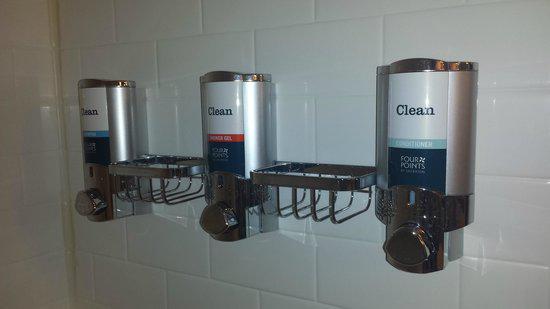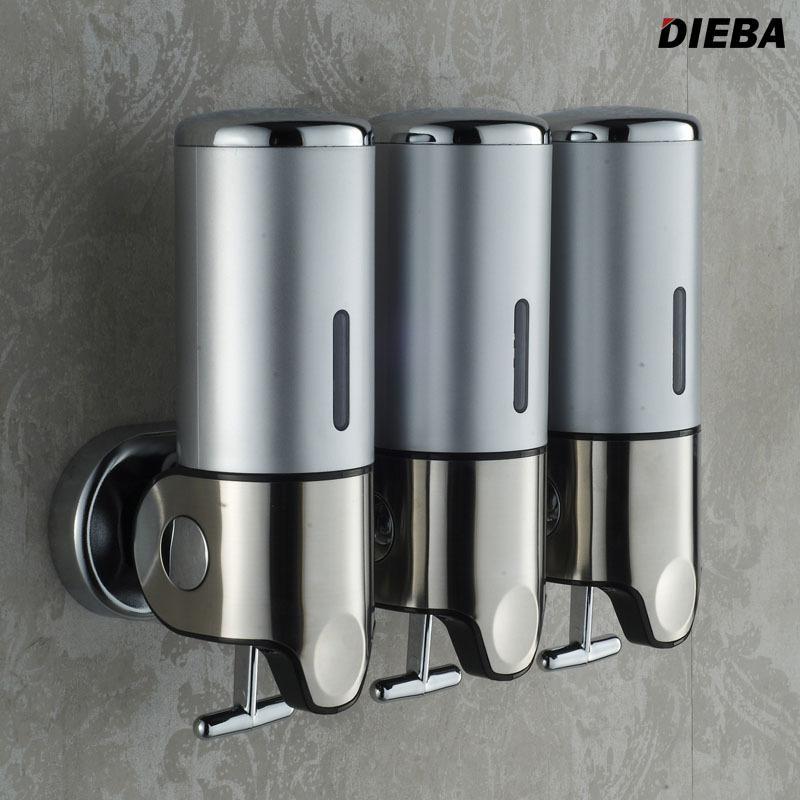The first image is the image on the left, the second image is the image on the right. Assess this claim about the two images: "All images include triple dispenser fixtures that mount on a wall, with the canisters close together side-by-side.". Correct or not? Answer yes or no. No. The first image is the image on the left, the second image is the image on the right. Analyze the images presented: Is the assertion "In the right image three dispensers have a silvered colored solid top." valid? Answer yes or no. Yes. 